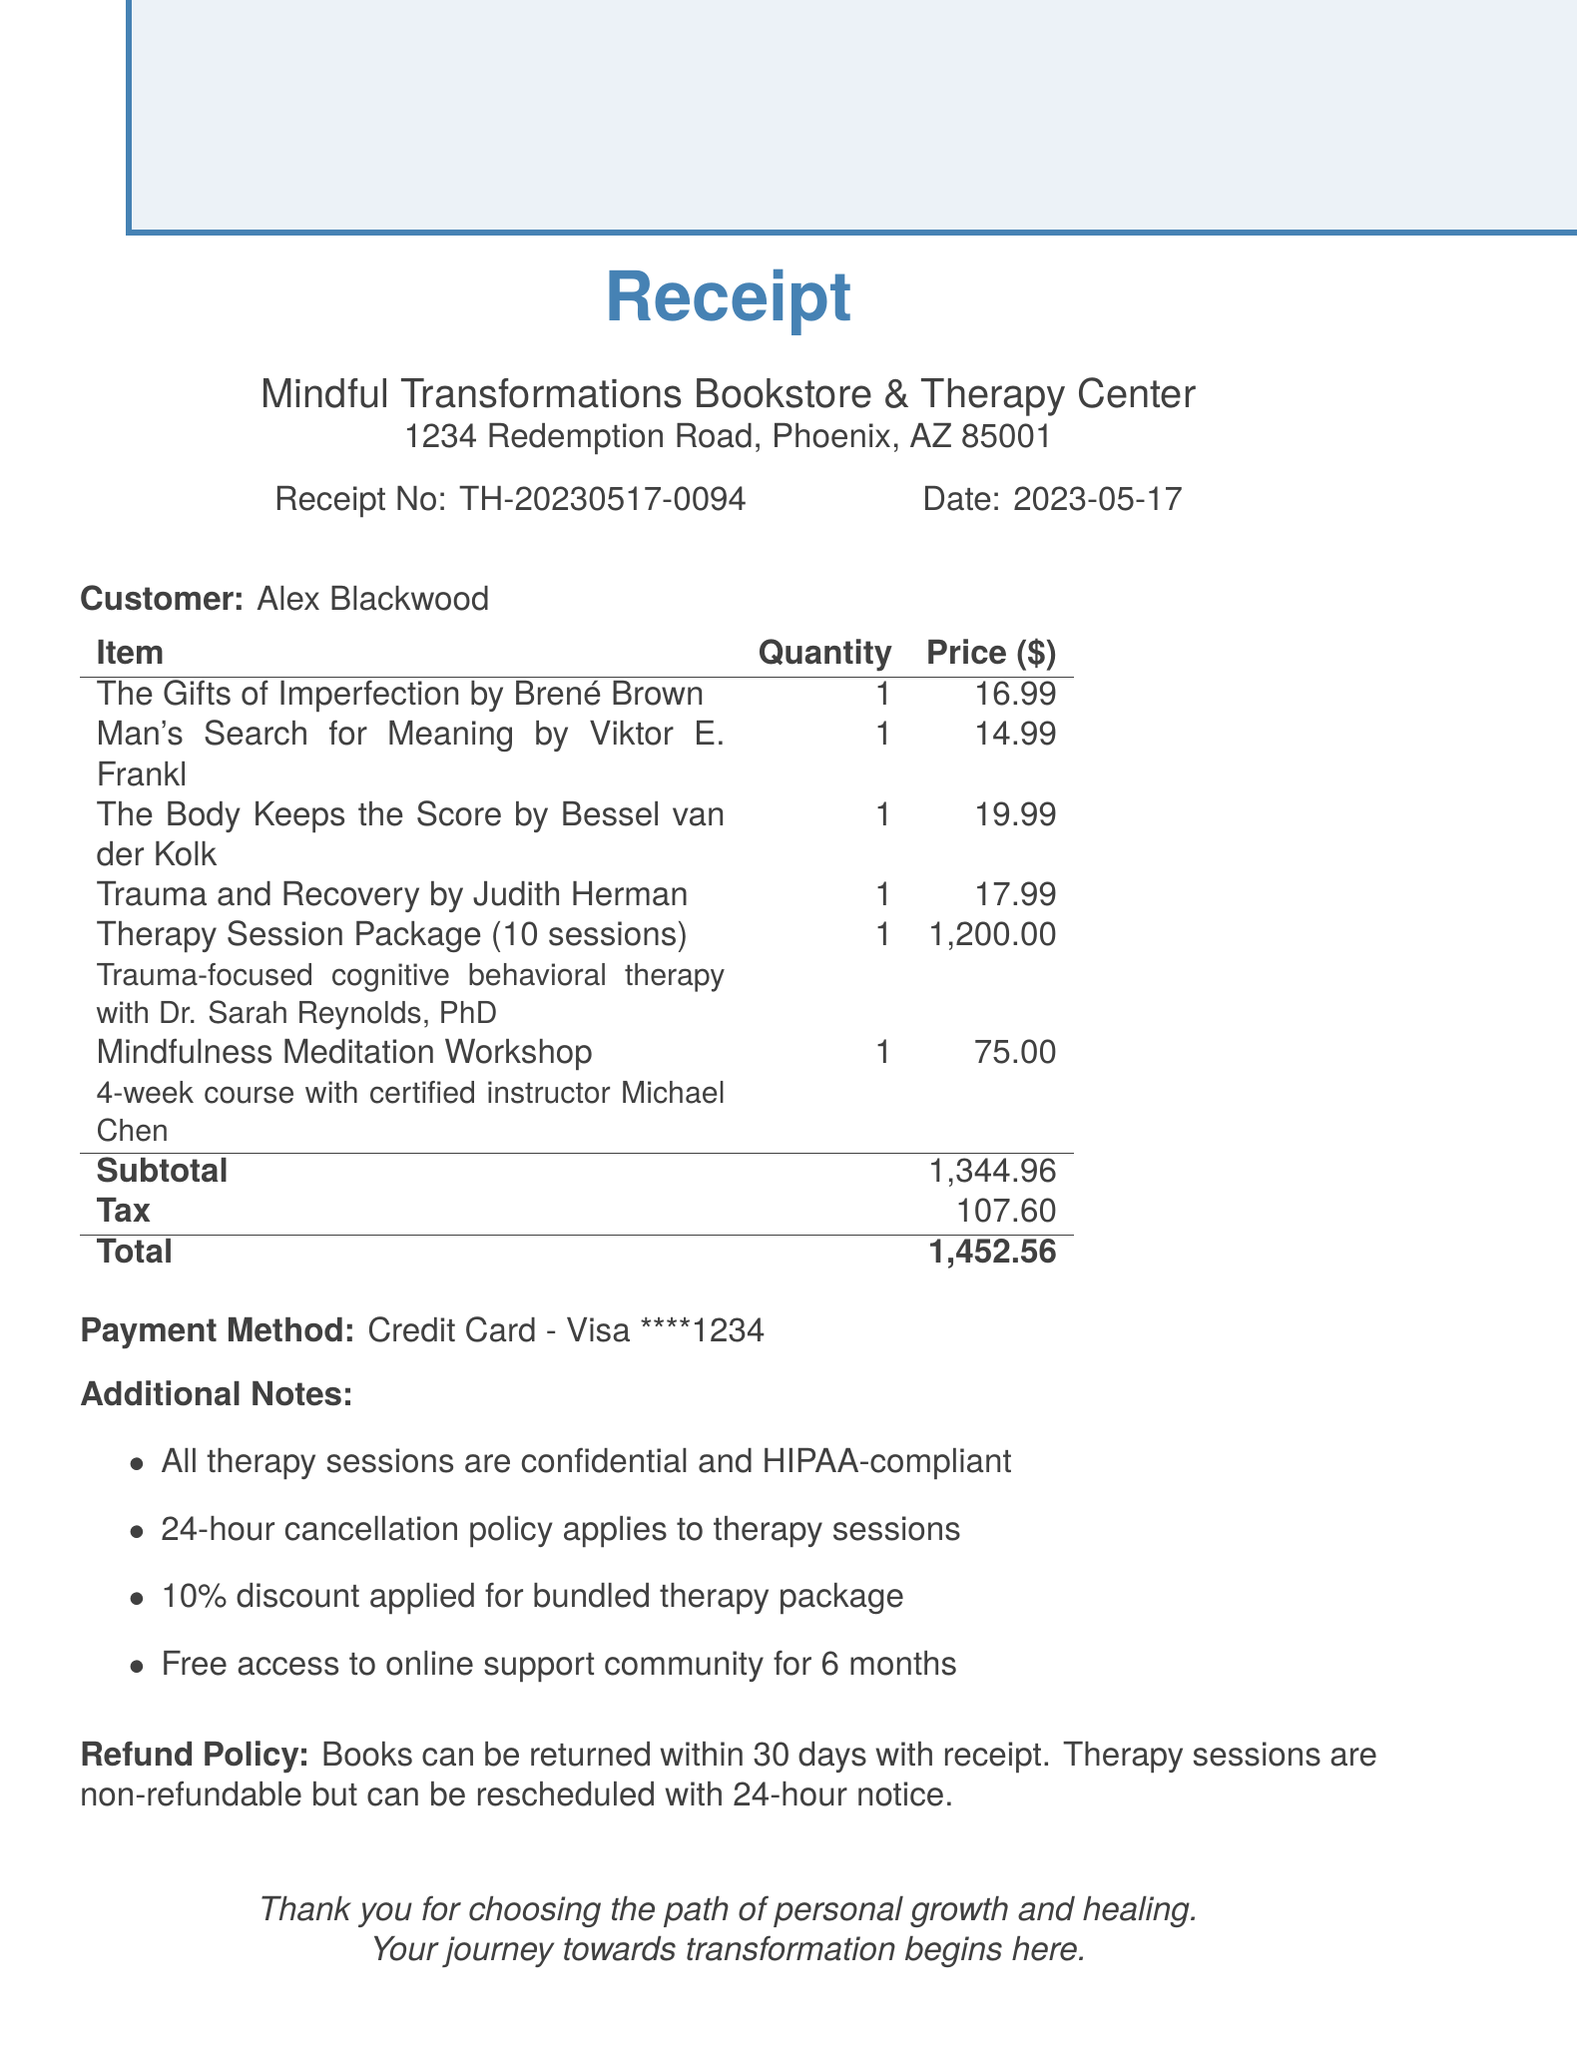What is the receipt number? The receipt number is listed at the top of the document for reference.
Answer: TH-20230517-0094 What is the date of the transaction? The date is specified on the receipt, indicating when the purchase was made.
Answer: 2023-05-17 Who is the vendor for these items? The vendor name appears at the beginning of the receipt, confirming where the transaction took place.
Answer: Mindful Transformations Bookstore & Therapy Center How many therapy sessions are included in the package? The details of the therapy session package indicate how many sessions are offered.
Answer: 10 sessions What is the total amount paid? The total is the cumulative amount at the bottom of the itemized list, representing the final charge.
Answer: 1,452.56 What type of therapy is included in the package? A description of the therapy provides insight into the approach being utilized.
Answer: Trauma-focused cognitive behavioral therapy What is the tax amount? The tax amount is specified separately in the pricing section of the receipt.
Answer: 107.60 How long is the free access to the support community? The duration of the free access is stated in the additional notes section of the receipt.
Answer: 6 months Are therapy sessions refundable? The refund policy outlines the conditions for returning or rescheduling services.
Answer: Non-refundable 